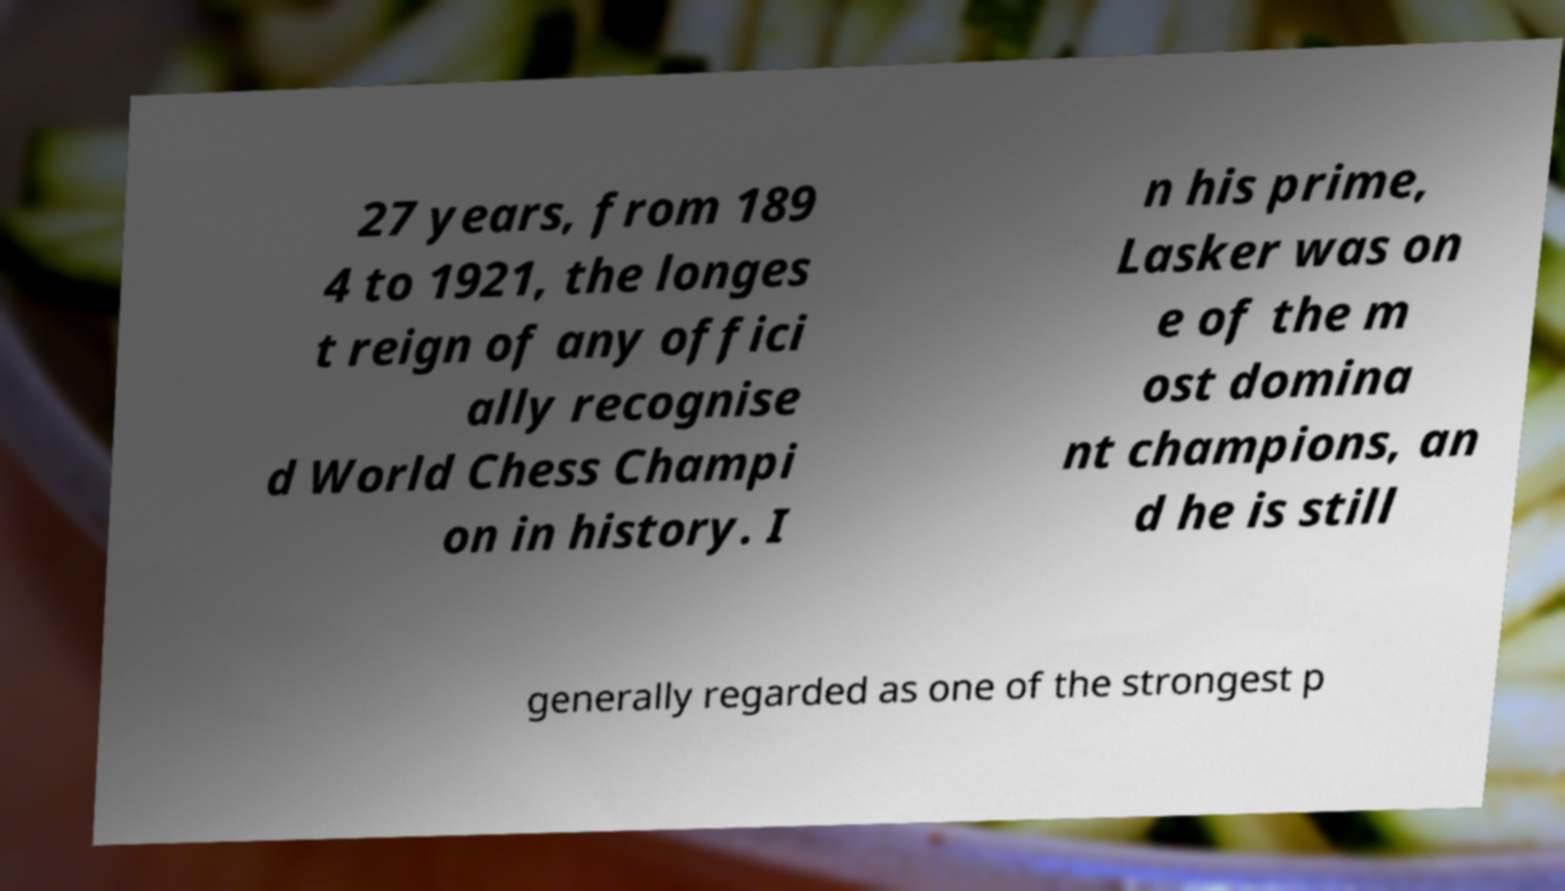Please identify and transcribe the text found in this image. 27 years, from 189 4 to 1921, the longes t reign of any offici ally recognise d World Chess Champi on in history. I n his prime, Lasker was on e of the m ost domina nt champions, an d he is still generally regarded as one of the strongest p 